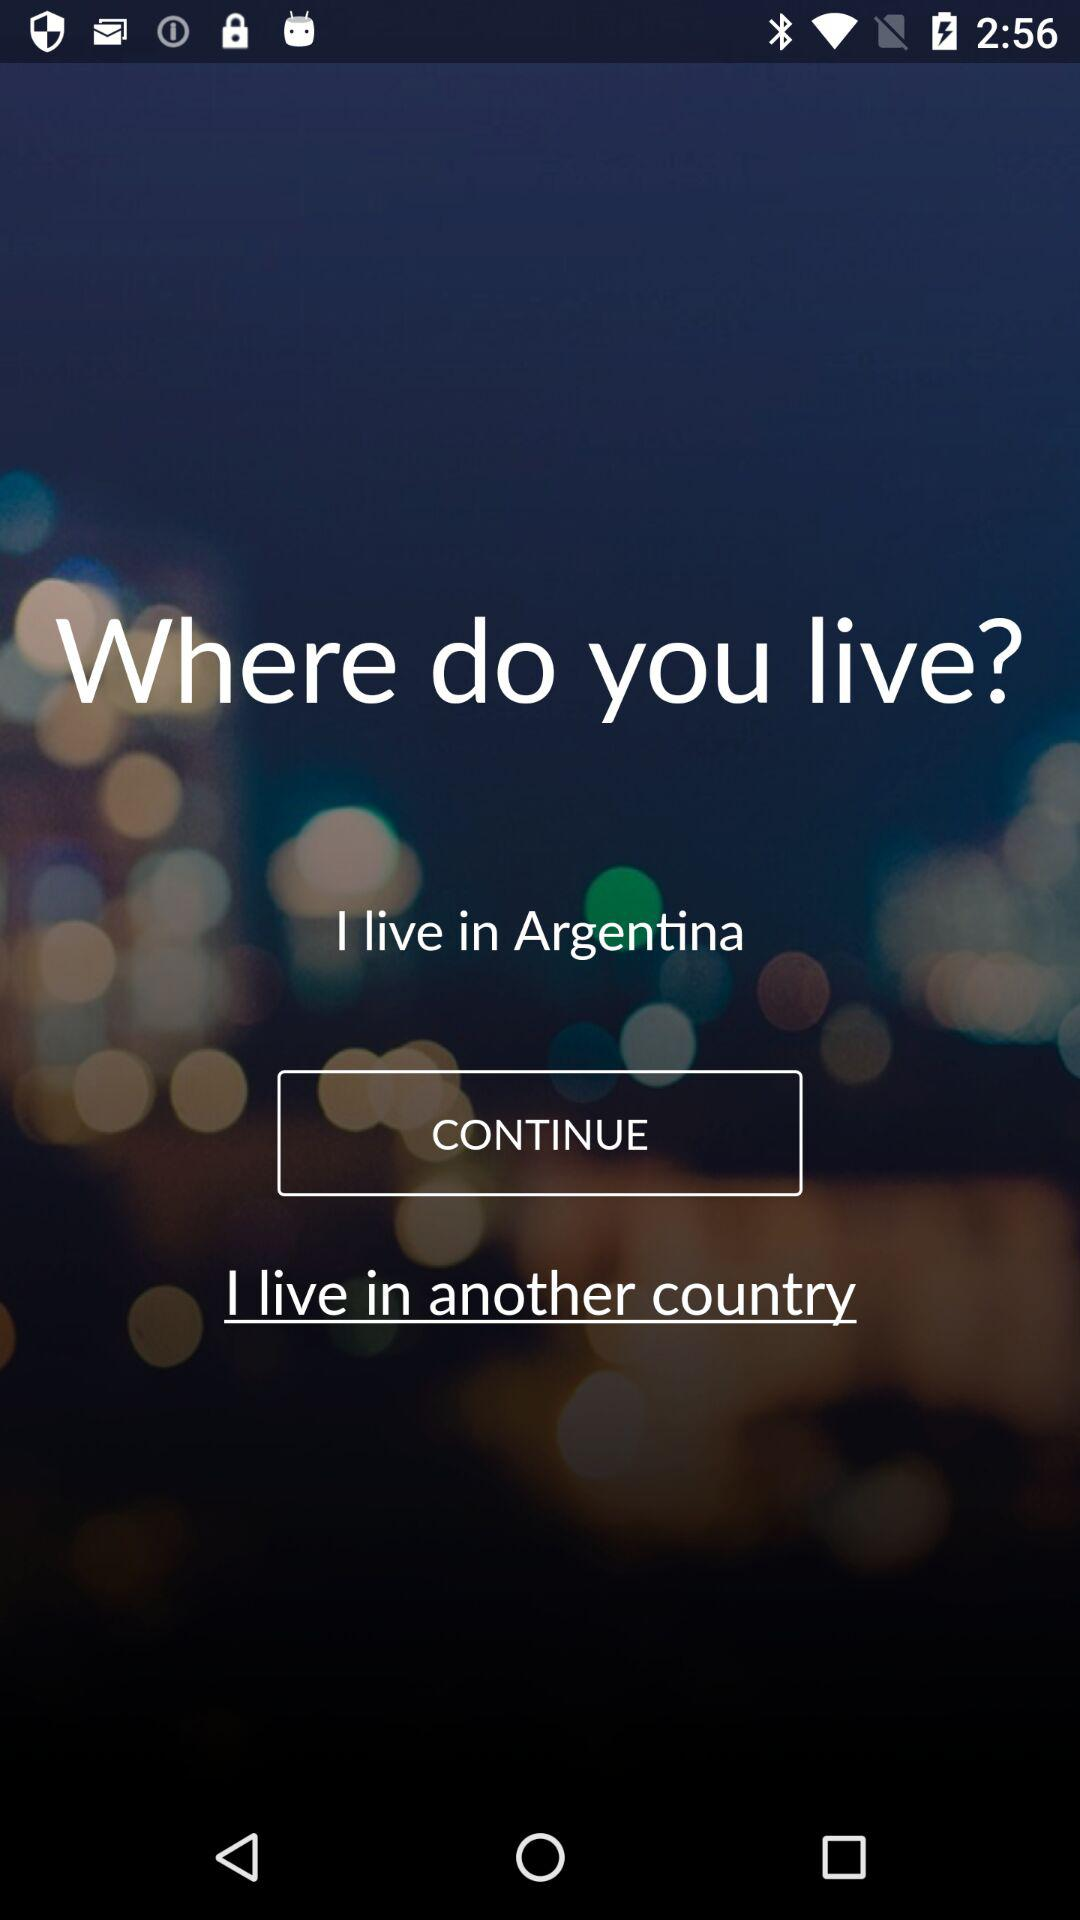What is the mentioned location? The mentioned location is Argentina. 